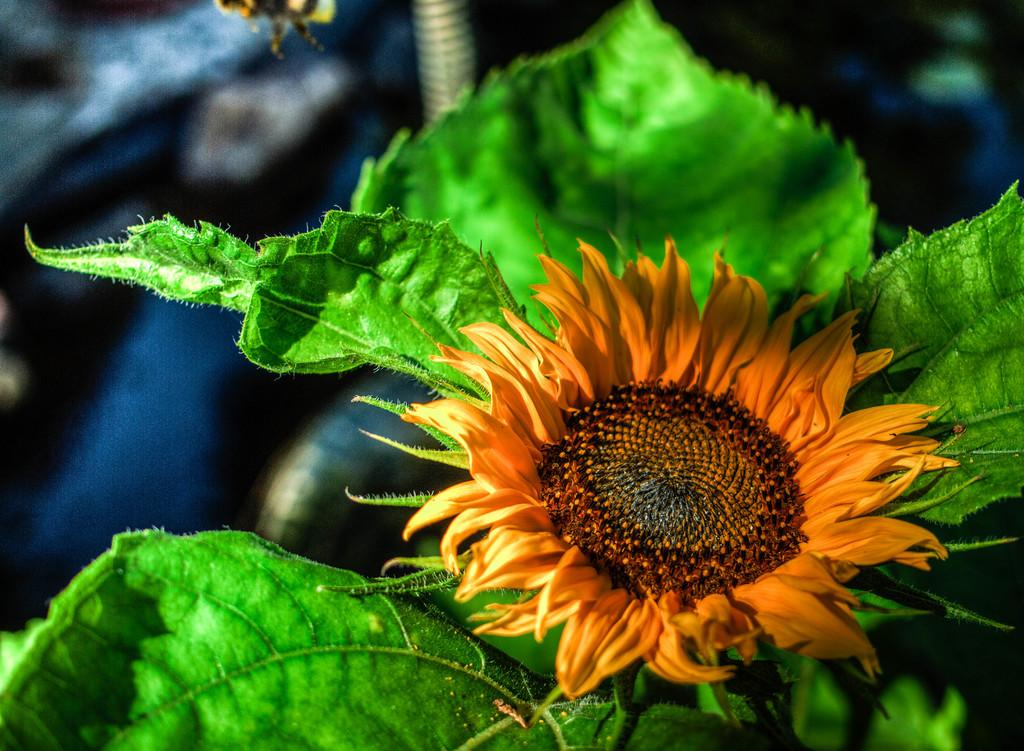What type of plant can be seen in the image? There is a flower in the image. What else is present on the plant besides the flower? There are leaves in the image. Can you describe the background of the image? The background of the image is blurry. What type of chain is wrapped around the jar in the image? There is no jar or chain present in the image; it only features a flower and leaves. 